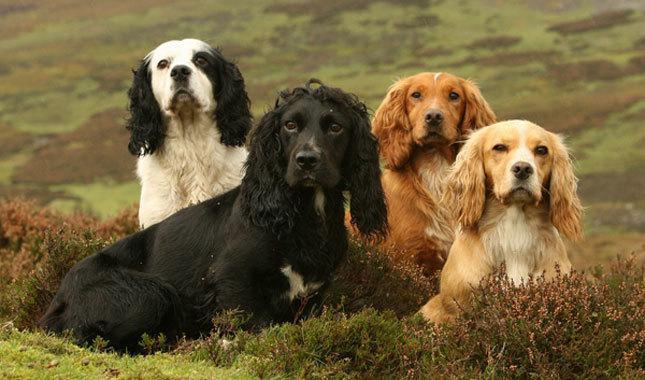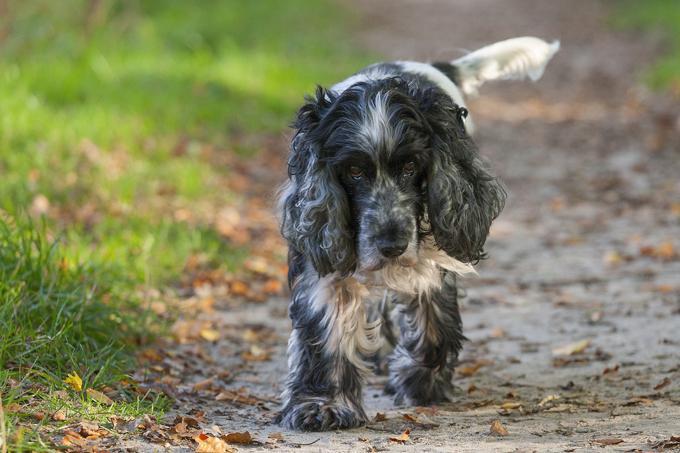The first image is the image on the left, the second image is the image on the right. Assess this claim about the two images: "At least three dogs, all of them the same breed, but different colors, are in one image.". Correct or not? Answer yes or no. Yes. 